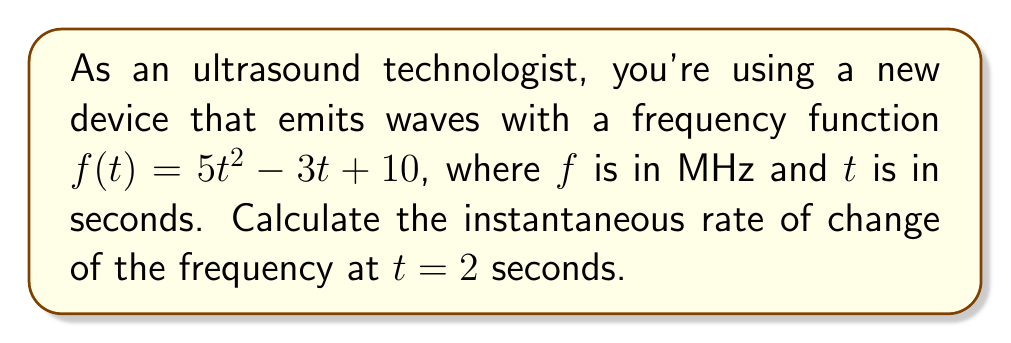What is the answer to this math problem? To find the instantaneous rate of change of the frequency at $t = 2$ seconds, we need to calculate the derivative of the frequency function $f(t)$ and then evaluate it at $t = 2$.

Step 1: Find the derivative of $f(t)$.
$$f(t) = 5t^2 - 3t + 10$$
$$f'(t) = 10t - 3$$

Step 2: Evaluate $f'(t)$ at $t = 2$.
$$f'(2) = 10(2) - 3$$
$$f'(2) = 20 - 3 = 17$$

The instantaneous rate of change at $t = 2$ seconds is 17 MHz/s.

This means that at exactly 2 seconds, the frequency of the ultrasound waves is increasing at a rate of 17 MHz per second.
Answer: 17 MHz/s 